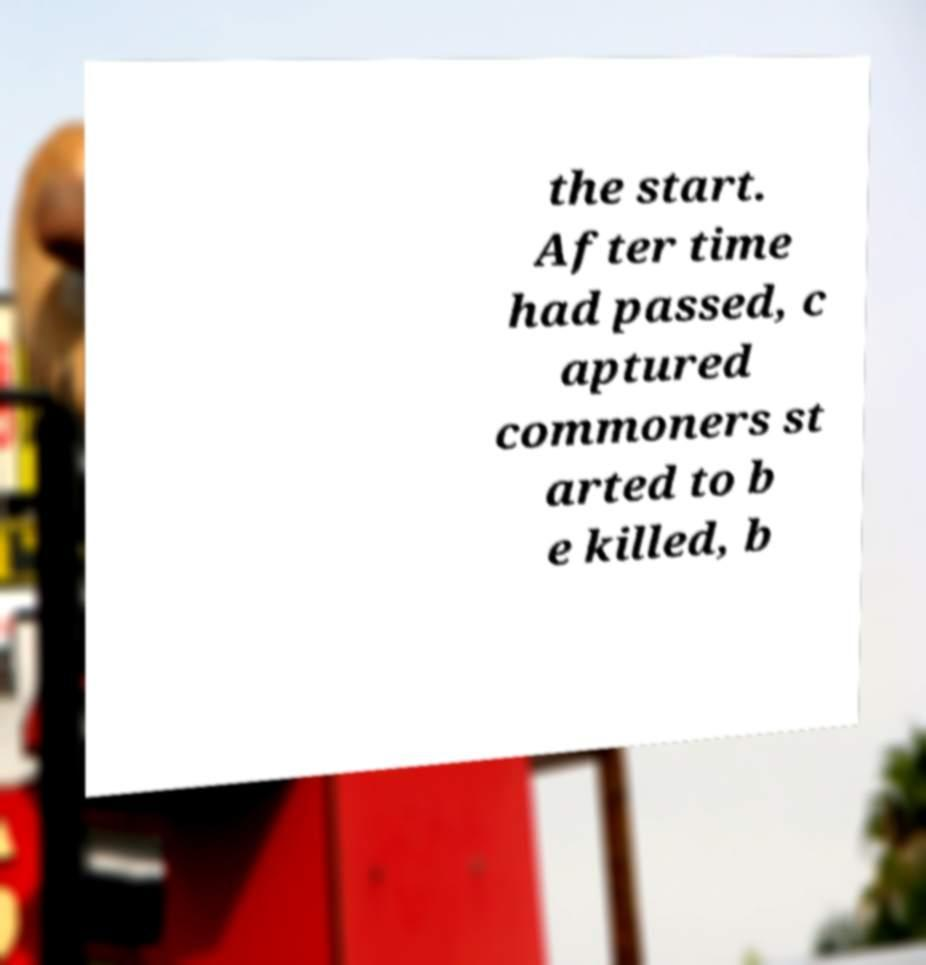I need the written content from this picture converted into text. Can you do that? the start. After time had passed, c aptured commoners st arted to b e killed, b 